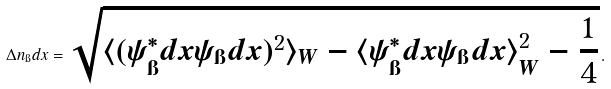<formula> <loc_0><loc_0><loc_500><loc_500>\Delta n _ { \i } d x = \sqrt { \langle ( \psi ^ { * } _ { \i } d x \psi _ { \i } d x ) ^ { 2 } \rangle _ { W } - \langle \psi ^ { * } _ { \i } d x \psi _ { \i } d x \rangle _ { W } ^ { 2 } - \frac { 1 } { 4 } } \, .</formula> 